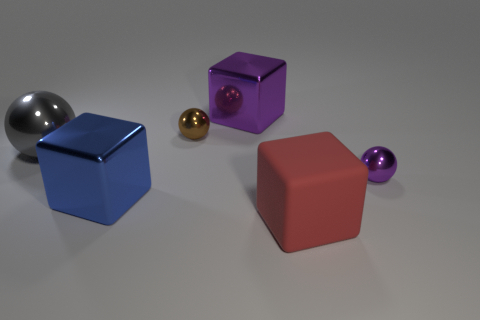What size is the blue cube that is made of the same material as the big gray sphere? The blue cube in the image appears to be a medium-sized object relative to the other shapes present. It is made of a glossy material similar to that of the large gray sphere, indicating they are made of the same or similar materials. 